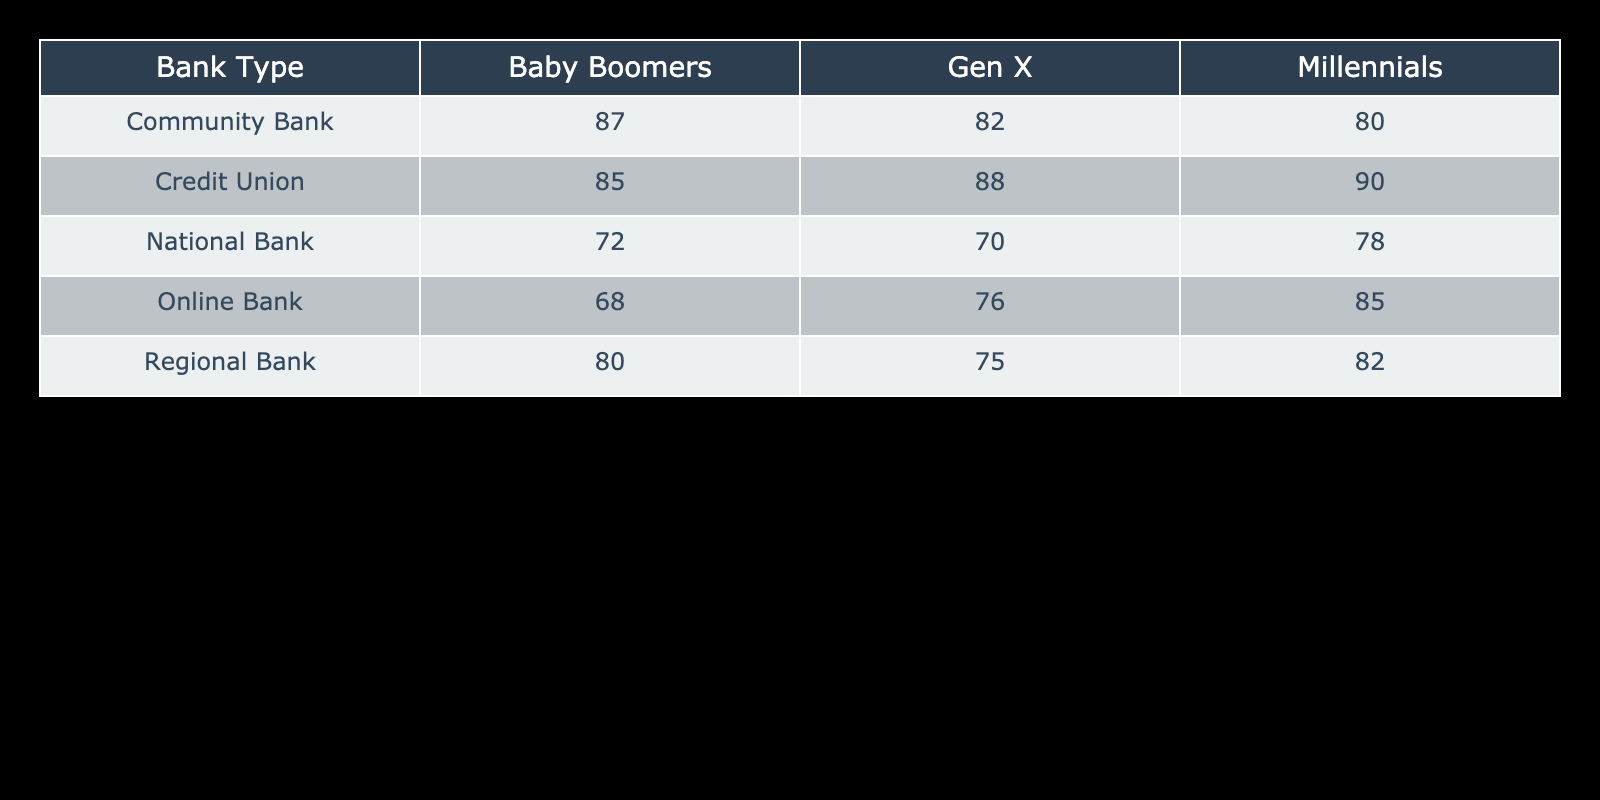What is the customer satisfaction rating for Millennials at Online Banks? The table shows the customer satisfaction rating for each demographic group at different bank types. For Millennials at Online Banks, the value is 85.
Answer: 85 Which demographic group has the highest satisfaction rating at Credit Unions? In the table, we can look at the values for Credit Unions across all demographic groups: Millennials (90), Gen X (88), and Baby Boomers (85). The highest is for Millennials at 90.
Answer: 90 What is the average customer satisfaction rating for Baby Boomers across all bank types? To find the average for Baby Boomers, we sum the ratings: 80 (Regional) + 72 (National) + 68 (Online) + 85 (Credit Union) + 87 (Community) = 392. There are 5 entries, so we calculate the average: 392/5 = 78.4.
Answer: 78.4 What is the lowest customer satisfaction rating for Gen X across all bank types? We inspect the Gen X ratings in the table: 75 (Regional), 70 (National), 76 (Online), 88 (Credit Union), and 82 (Community). The lowest rating is 70 from the National Bank.
Answer: 70 Is the customer satisfaction rating for Baby Boomers at Community Banks higher than that at National Banks? According to the table, the rating for Baby Boomers at Community Banks is 87, while at National Banks it is 72. Since 87 is greater than 72, the statement is true.
Answer: Yes What is the difference in customer satisfaction ratings between Millennials at Credit Unions and Online Banks? The rating for Millennials at Credit Unions is 90, and at Online Banks, it is 85. To find the difference: 90 - 85 = 5.
Answer: 5 Which bank type has the second highest average customer satisfaction rating across all demographic groups? Calculate the average ratings for each bank type: Regional Bank (82 + 75 + 80 = 237, average = 79), National Bank (78 + 70 + 72 = 220, average = 73.3), Online Bank (85 + 76 + 68 = 229, average = 76.3), Credit Union (90 + 88 + 85 = 263, average = 87.7), Community Bank (80 + 82 + 87 = 249, average = 83). The second highest average rating is for Community Bank at 83.
Answer: Community Bank What is the highest customer satisfaction rating among all the bank types and demographic groups? The maximum rating in the table is 90, which is from Millennials at Credit Unions.
Answer: 90 